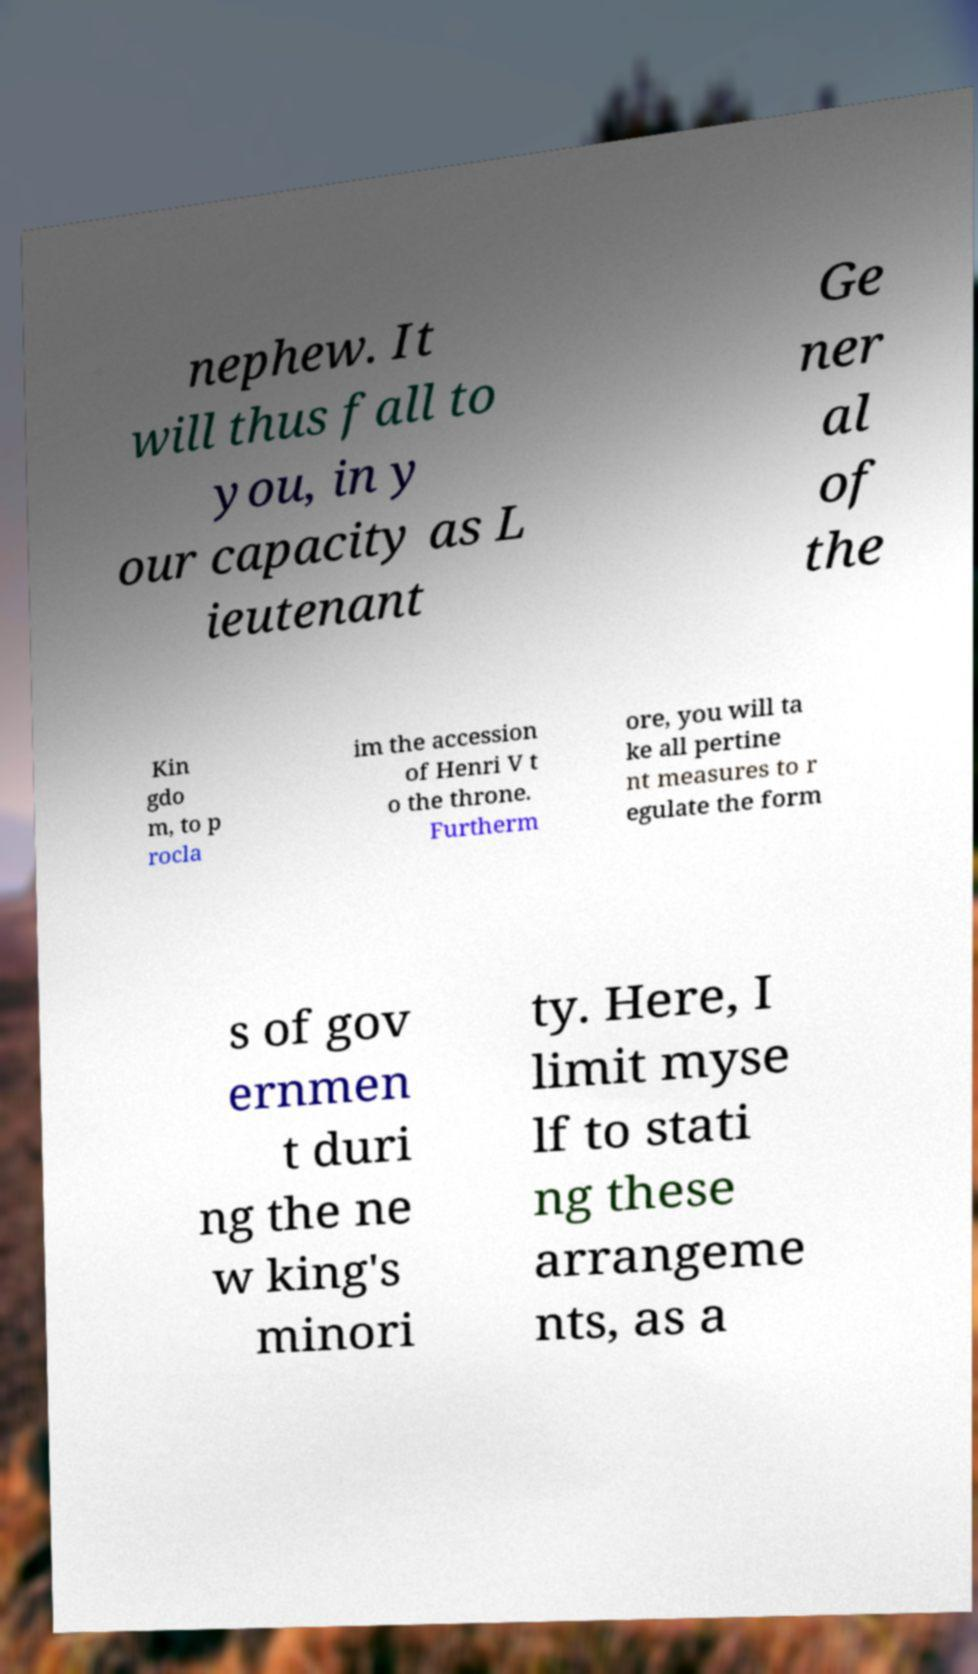I need the written content from this picture converted into text. Can you do that? nephew. It will thus fall to you, in y our capacity as L ieutenant Ge ner al of the Kin gdo m, to p rocla im the accession of Henri V t o the throne. Furtherm ore, you will ta ke all pertine nt measures to r egulate the form s of gov ernmen t duri ng the ne w king's minori ty. Here, I limit myse lf to stati ng these arrangeme nts, as a 